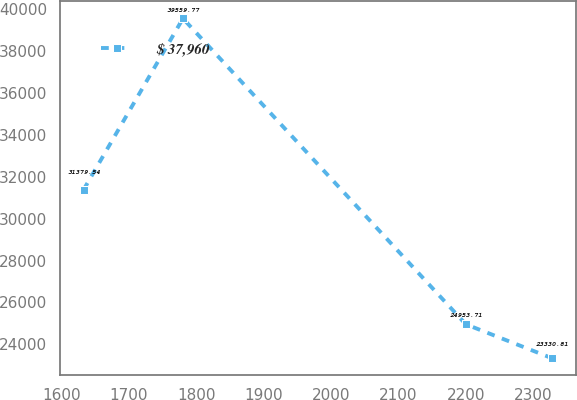Convert chart to OTSL. <chart><loc_0><loc_0><loc_500><loc_500><line_chart><ecel><fcel>$ 37,960<nl><fcel>1632.44<fcel>31379.5<nl><fcel>1780.06<fcel>39559.8<nl><fcel>2200.23<fcel>24953.7<nl><fcel>2328.43<fcel>23330.8<nl></chart> 